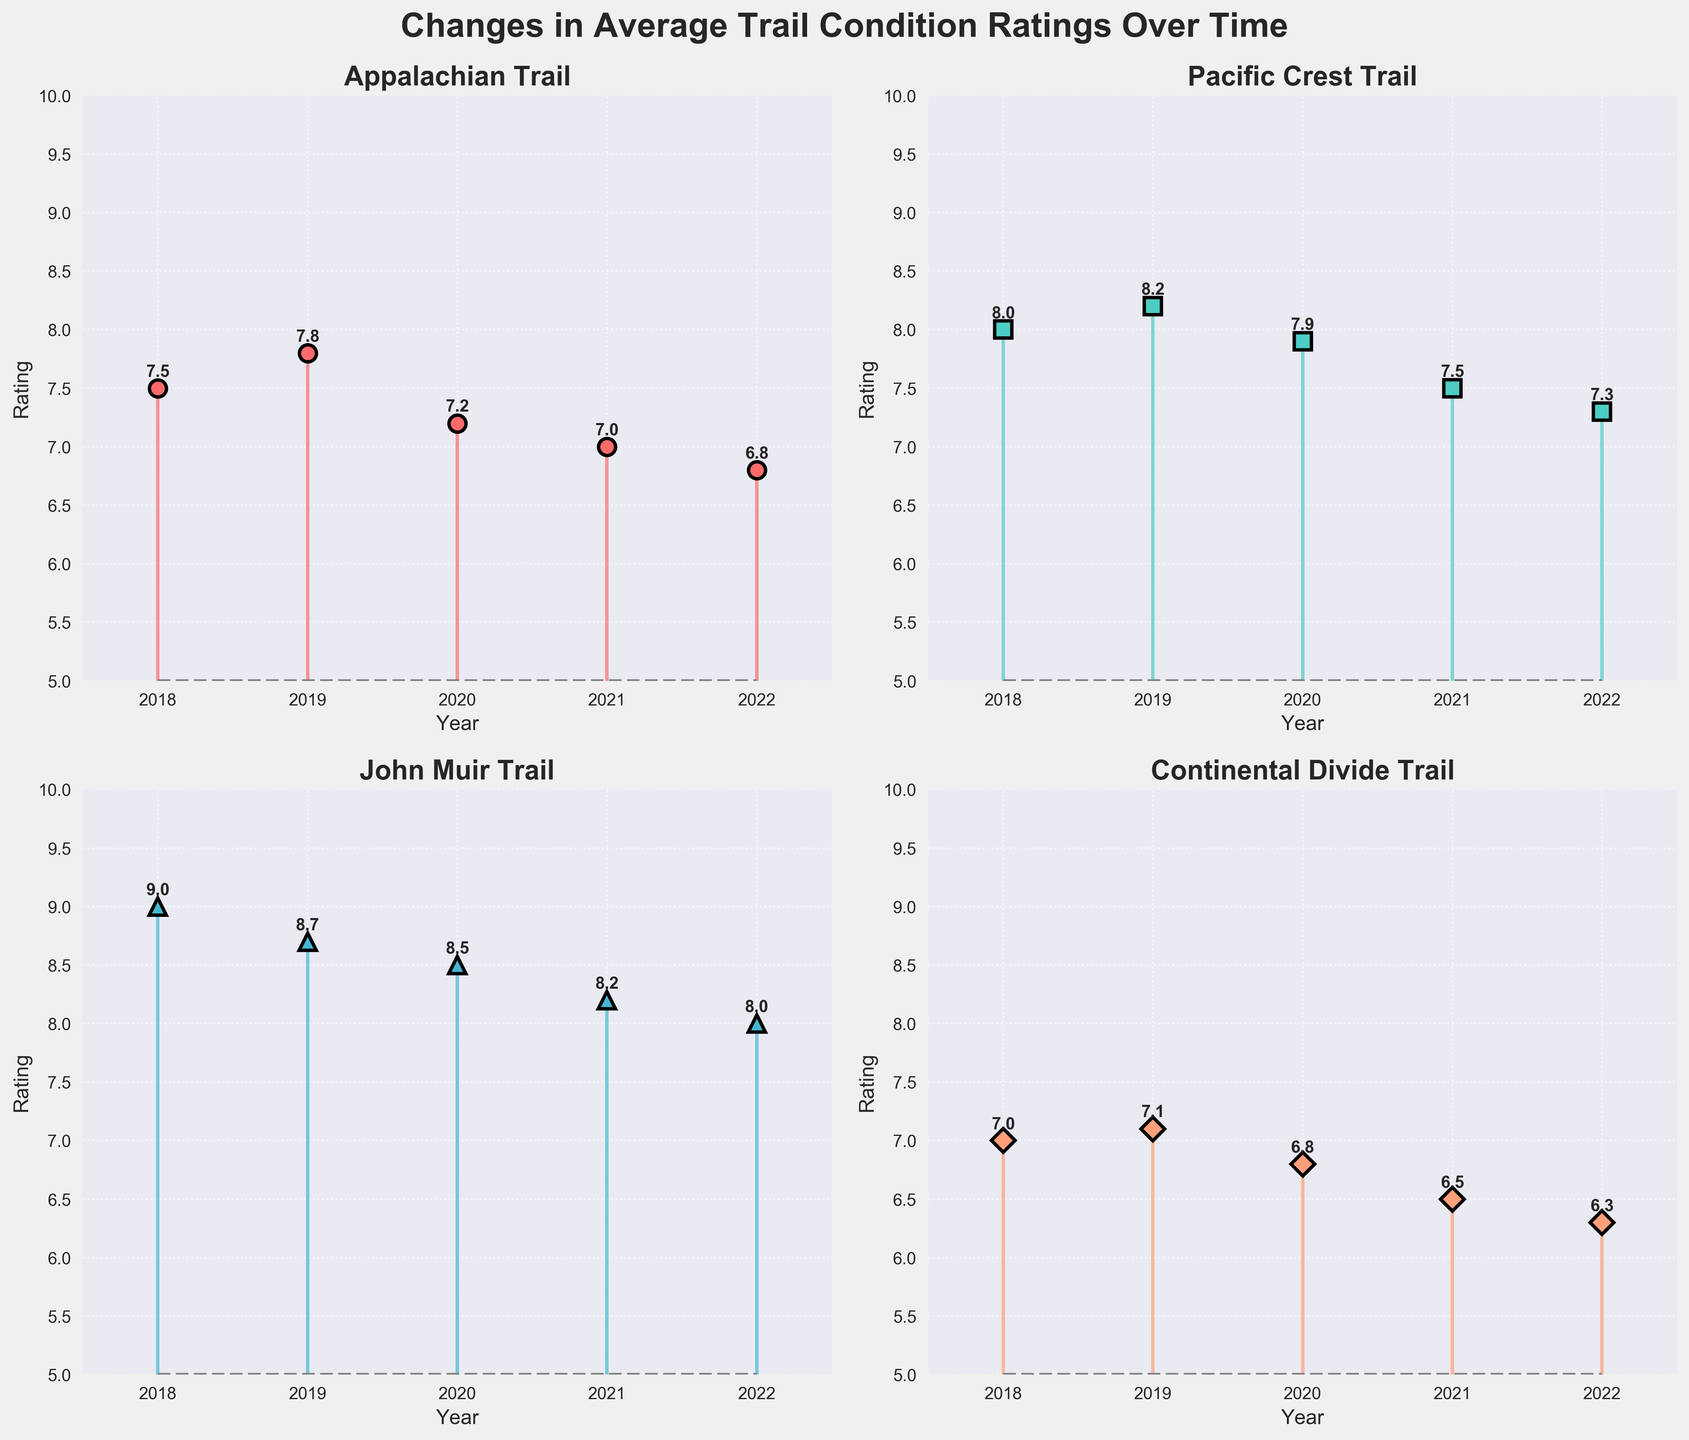What's the title of the figure? The title is located at the top of the figure and usually describes the main theme or focus. In this case, it is prominently displayed in large, bold font.
Answer: Changes in Average Trail Condition Ratings Over Time How many subplots are in the figure? The figure consists of four smaller plots arranged in a 2x2 grid, as can be seen from the layout.
Answer: 4 Which trail had the highest rating in 2019? By inspecting each subplot, we can find that the John Muir Trail has the highest rating. It shows 8.7 for the year 2019.
Answer: John Muir Trail In which year did the Appalachian Trail have its lowest average rating? By examining the subplot for the Appalachian Trail, we observe that the lowest point on the stem plot is in 2022 with a rating of 6.8.
Answer: 2022 What is the overall trend in the rating for the Pacific Crest Trail from 2018 to 2022? The stem plot for the Pacific Crest Trail shows a declining trend, with the ratings starting at 8.0 in 2018 and decreasing to 7.3 in 2022.
Answer: Decreasing Which trail showed the smallest decline in ratings from 2018 to 2022? To determine this, we calculate the difference between the rating in 2018 and 2022 for each trail. The John Muir Trail shows the smallest decline, from 9.0 in 2018 to 8.0 in 2022, a drop of 1.0.
Answer: John Muir Trail Compare the rating change between John Muir Trail and Continental Divide Trail from 2018 to 2022. Which trail experienced a greater decline? By comparing the 2018 and 2022 ratings for both trails, we see that the John Muir Trail declined by 1.0 (from 9.0 to 8.0), while the Continental Divide Trail declined by 0.7 (from 7.0 to 6.3). So, the John Muir Trail experienced a greater decline.
Answer: John Muir Trail What was the approximate average rating for the Appalachian Trail over the years provided? Sum the ratings for the Appalachian Trail (7.5 + 7.8 + 7.2 + 7.0 + 6.8) and then divide by 5 (the number of years). The result is approximately 36.3 / 5 = 7.26.
Answer: 7.26 Which year had the highest average rating across all trails? By looking at the individual ratings in each subplot for each year and averaging them:
- 2018: (7.5 + 8.0 + 9.0 + 7.0) / 4 = 7.88
- 2019: (7.8 + 8.2 + 8.7 + 7.1) / 4 = 7.95
- 2020: (7.2 + 7.9 + 8.5 + 6.8) / 4 = 7.6
- 2021: (7.0 + 7.5 + 8.2 + 6.5) / 4 = 7.3
- 2022: (6.8 + 7.3 + 8.0 + 6.3) / 4 = 7.1
2019 has the highest average rating of 7.95 across all trails.
Answer: 2019 What is the difference in rating between the highest point and the lowest point for the Pacific Crest Trail? The highest rating for the Pacific Crest Trail is 8.2 in 2019, and the lowest is 7.3 in 2022. The difference is 8.2 - 7.3 = 0.9.
Answer: 0.9 